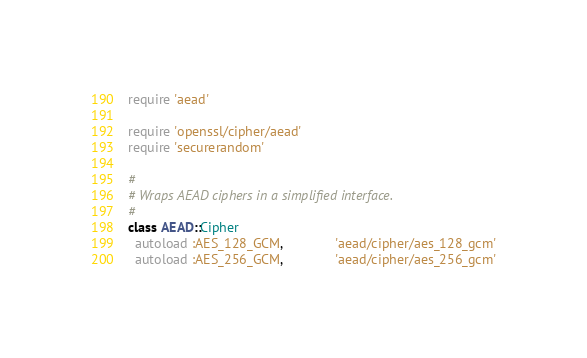<code> <loc_0><loc_0><loc_500><loc_500><_Ruby_>require 'aead'

require 'openssl/cipher/aead'
require 'securerandom'

#
# Wraps AEAD ciphers in a simplified interface.
#
class AEAD::Cipher
  autoload :AES_128_GCM,              'aead/cipher/aes_128_gcm'
  autoload :AES_256_GCM,              'aead/cipher/aes_256_gcm'</code> 